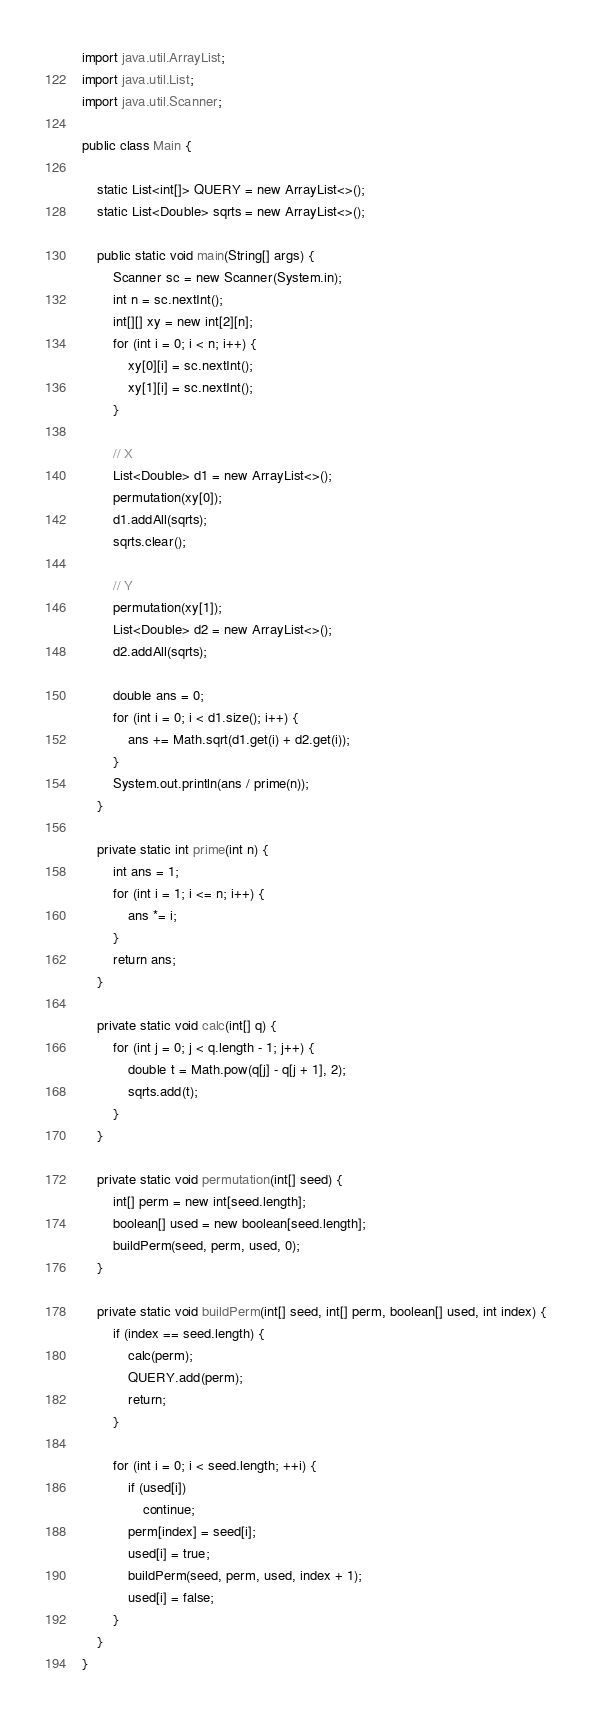Convert code to text. <code><loc_0><loc_0><loc_500><loc_500><_Java_>import java.util.ArrayList;
import java.util.List;
import java.util.Scanner;

public class Main {

    static List<int[]> QUERY = new ArrayList<>();
    static List<Double> sqrts = new ArrayList<>();

    public static void main(String[] args) {
        Scanner sc = new Scanner(System.in);
        int n = sc.nextInt();
        int[][] xy = new int[2][n];
        for (int i = 0; i < n; i++) {
            xy[0][i] = sc.nextInt();
            xy[1][i] = sc.nextInt();
        }

        // X
        List<Double> d1 = new ArrayList<>();
        permutation(xy[0]);
        d1.addAll(sqrts);
        sqrts.clear();

        // Y
        permutation(xy[1]);
        List<Double> d2 = new ArrayList<>();
        d2.addAll(sqrts);

        double ans = 0;
        for (int i = 0; i < d1.size(); i++) {
            ans += Math.sqrt(d1.get(i) + d2.get(i));
        }
        System.out.println(ans / prime(n));
    }

    private static int prime(int n) {
        int ans = 1;
        for (int i = 1; i <= n; i++) {
            ans *= i;
        }
        return ans;
    }

    private static void calc(int[] q) {
        for (int j = 0; j < q.length - 1; j++) {
            double t = Math.pow(q[j] - q[j + 1], 2);
            sqrts.add(t);
        }
    }

    private static void permutation(int[] seed) {
        int[] perm = new int[seed.length];
        boolean[] used = new boolean[seed.length];
        buildPerm(seed, perm, used, 0);
    }

    private static void buildPerm(int[] seed, int[] perm, boolean[] used, int index) {
        if (index == seed.length) {
            calc(perm);
            QUERY.add(perm);
            return;
        }

        for (int i = 0; i < seed.length; ++i) {
            if (used[i])
                continue;
            perm[index] = seed[i];
            used[i] = true;
            buildPerm(seed, perm, used, index + 1);
            used[i] = false;
        }
    }
}

</code> 